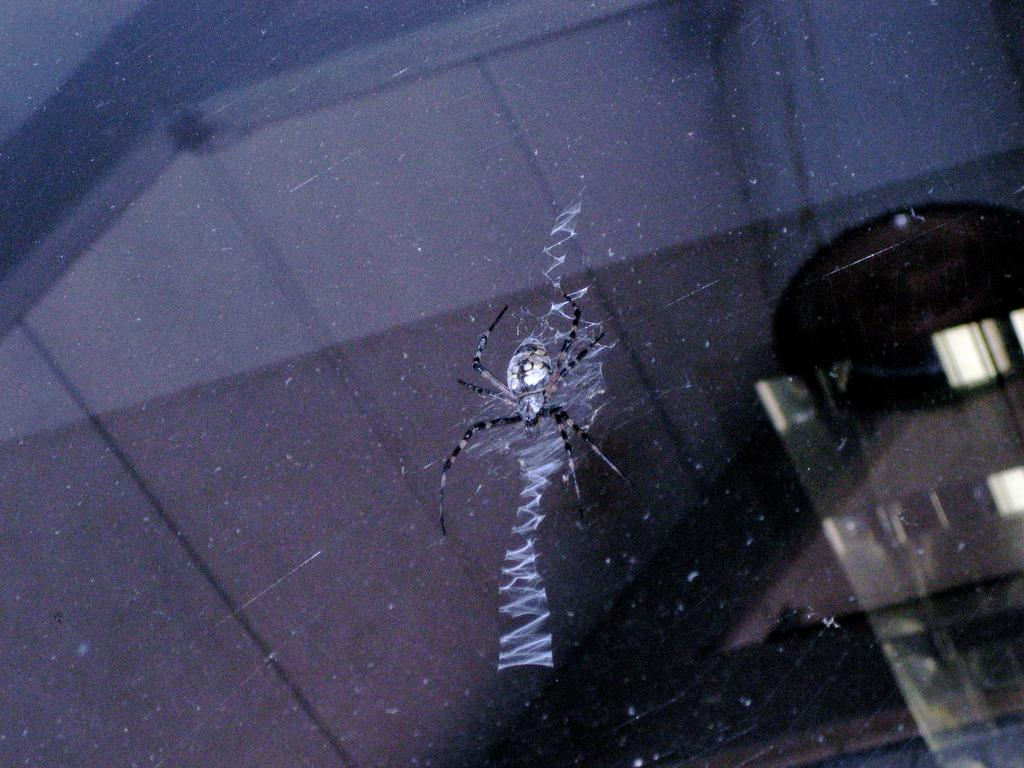What is the main subject of the image? The main subject of the image is a spider. Where is the spider located in the image? The spider is on a glass. How does the spider drain the water from the glass in the image? There is no indication in the image that the spider is draining water from the glass, and spiders do not have the ability to drain water. 